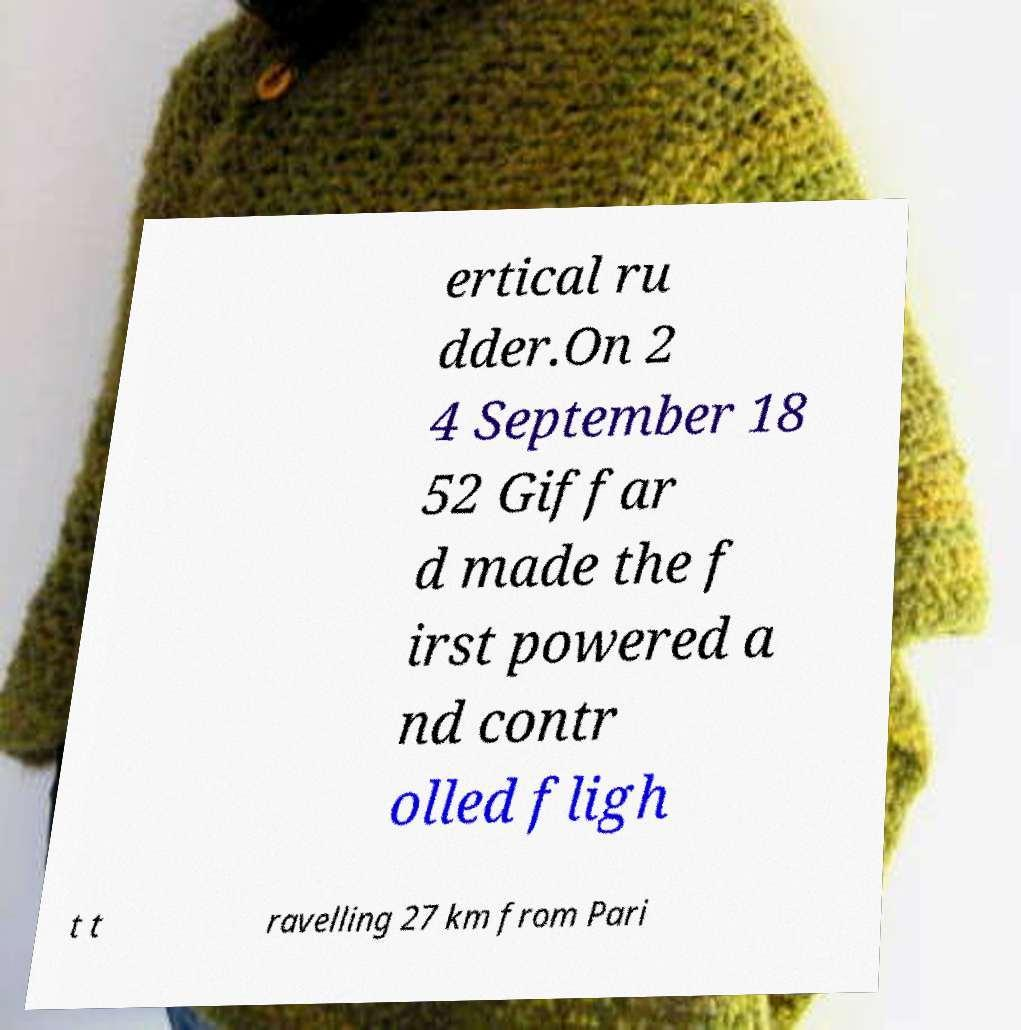Can you accurately transcribe the text from the provided image for me? ertical ru dder.On 2 4 September 18 52 Giffar d made the f irst powered a nd contr olled fligh t t ravelling 27 km from Pari 